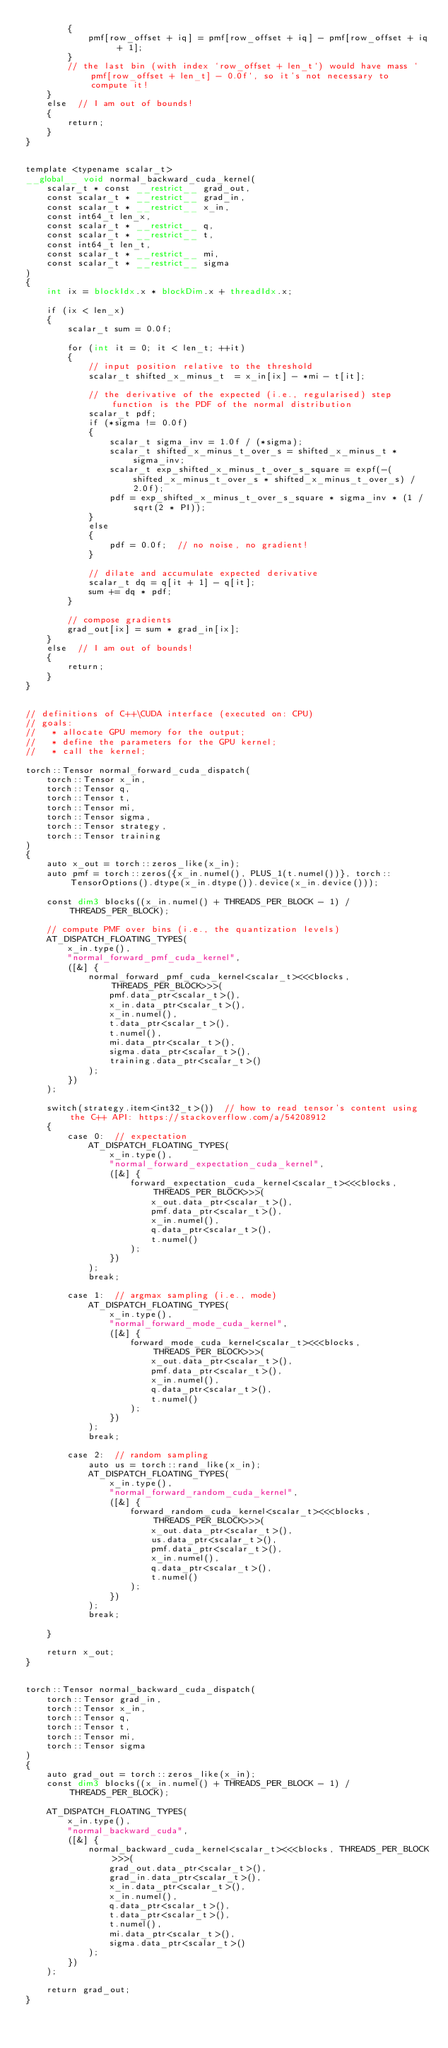<code> <loc_0><loc_0><loc_500><loc_500><_Cuda_>        {
            pmf[row_offset + iq] = pmf[row_offset + iq] - pmf[row_offset + iq + 1];
        }
        // the last bin (with index `row_offset + len_t`) would have mass `pmf[row_offset + len_t] - 0.0f`, so it's not necessary to compute it!
    }
    else  // I am out of bounds!
    {
        return;
    }
}


template <typename scalar_t>
__global__ void normal_backward_cuda_kernel(
    scalar_t * const __restrict__ grad_out,
    const scalar_t * __restrict__ grad_in,
    const scalar_t * __restrict__ x_in,
    const int64_t len_x,
    const scalar_t * __restrict__ q,
    const scalar_t * __restrict__ t,
    const int64_t len_t,
    const scalar_t * __restrict__ mi,
    const scalar_t * __restrict__ sigma
)
{
    int ix = blockIdx.x * blockDim.x + threadIdx.x;

    if (ix < len_x)
    {
        scalar_t sum = 0.0f;

        for (int it = 0; it < len_t; ++it)
        {
            // input position relative to the threshold
            scalar_t shifted_x_minus_t  = x_in[ix] - *mi - t[it];

            // the derivative of the expected (i.e., regularised) step function is the PDF of the normal distribution
            scalar_t pdf;
            if (*sigma != 0.0f)
            {
                scalar_t sigma_inv = 1.0f / (*sigma);
                scalar_t shifted_x_minus_t_over_s = shifted_x_minus_t * sigma_inv;
                scalar_t exp_shifted_x_minus_t_over_s_square = expf(-(shifted_x_minus_t_over_s * shifted_x_minus_t_over_s) / 2.0f);
                pdf = exp_shifted_x_minus_t_over_s_square * sigma_inv * (1 / sqrt(2 * PI));
            }
            else
            {
                pdf = 0.0f;  // no noise, no gradient!
            }

            // dilate and accumulate expected derivative
            scalar_t dq = q[it + 1] - q[it];
            sum += dq * pdf;
        }

        // compose gradients
        grad_out[ix] = sum * grad_in[ix];
    }
    else  // I am out of bounds!
    {
        return;
    }
}


// definitions of C++\CUDA interface (executed on: CPU)
// goals:
//   * allocate GPU memory for the output;
//   * define the parameters for the GPU kernel;
//   * call the kernel;

torch::Tensor normal_forward_cuda_dispatch(
    torch::Tensor x_in,
    torch::Tensor q,
    torch::Tensor t,
    torch::Tensor mi,
    torch::Tensor sigma,
    torch::Tensor strategy,
    torch::Tensor training
)
{
    auto x_out = torch::zeros_like(x_in);
    auto pmf = torch::zeros({x_in.numel(), PLUS_1(t.numel())}, torch::TensorOptions().dtype(x_in.dtype()).device(x_in.device()));

    const dim3 blocks((x_in.numel() + THREADS_PER_BLOCK - 1) / THREADS_PER_BLOCK);

    // compute PMF over bins (i.e., the quantization levels)
    AT_DISPATCH_FLOATING_TYPES(
        x_in.type(),
        "normal_forward_pmf_cuda_kernel",
        ([&] {
            normal_forward_pmf_cuda_kernel<scalar_t><<<blocks, THREADS_PER_BLOCK>>>(
                pmf.data_ptr<scalar_t>(),
                x_in.data_ptr<scalar_t>(),
                x_in.numel(),
                t.data_ptr<scalar_t>(),
                t.numel(),
                mi.data_ptr<scalar_t>(),
                sigma.data_ptr<scalar_t>(),
                training.data_ptr<scalar_t>()
            );
        })
    );

    switch(strategy.item<int32_t>())  // how to read tensor's content using the C++ API: https://stackoverflow.com/a/54208912
    {
        case 0:  // expectation
            AT_DISPATCH_FLOATING_TYPES(
                x_in.type(),
                "normal_forward_expectation_cuda_kernel",
                ([&] {
                    forward_expectation_cuda_kernel<scalar_t><<<blocks, THREADS_PER_BLOCK>>>(
                        x_out.data_ptr<scalar_t>(),
                        pmf.data_ptr<scalar_t>(),
                        x_in.numel(),
                        q.data_ptr<scalar_t>(),
                        t.numel()
                    );
                })
            );
            break;

        case 1:  // argmax sampling (i.e., mode)
            AT_DISPATCH_FLOATING_TYPES(
                x_in.type(),
                "normal_forward_mode_cuda_kernel",
                ([&] {
                    forward_mode_cuda_kernel<scalar_t><<<blocks, THREADS_PER_BLOCK>>>(
                        x_out.data_ptr<scalar_t>(),
                        pmf.data_ptr<scalar_t>(),
                        x_in.numel(),
                        q.data_ptr<scalar_t>(),
                        t.numel()
                    );
                })
            );
            break;

        case 2:  // random sampling
            auto us = torch::rand_like(x_in);
            AT_DISPATCH_FLOATING_TYPES(
                x_in.type(),
                "normal_forward_random_cuda_kernel",
                ([&] {
                    forward_random_cuda_kernel<scalar_t><<<blocks, THREADS_PER_BLOCK>>>(
                        x_out.data_ptr<scalar_t>(),
                        us.data_ptr<scalar_t>(),
                        pmf.data_ptr<scalar_t>(),
                        x_in.numel(),
                        q.data_ptr<scalar_t>(),
                        t.numel()
                    );
                })
            );
            break;

    }

    return x_out;
}


torch::Tensor normal_backward_cuda_dispatch(
    torch::Tensor grad_in,
    torch::Tensor x_in,
    torch::Tensor q,
    torch::Tensor t,
    torch::Tensor mi,
    torch::Tensor sigma
)
{
    auto grad_out = torch::zeros_like(x_in);
    const dim3 blocks((x_in.numel() + THREADS_PER_BLOCK - 1) / THREADS_PER_BLOCK);

    AT_DISPATCH_FLOATING_TYPES(
        x_in.type(),
        "normal_backward_cuda",
        ([&] {
            normal_backward_cuda_kernel<scalar_t><<<blocks, THREADS_PER_BLOCK>>>(
                grad_out.data_ptr<scalar_t>(),
                grad_in.data_ptr<scalar_t>(),
                x_in.data_ptr<scalar_t>(),
                x_in.numel(),
                q.data_ptr<scalar_t>(),
                t.data_ptr<scalar_t>(),
                t.numel(),
                mi.data_ptr<scalar_t>(),
                sigma.data_ptr<scalar_t>()
            );
        })
    );

    return grad_out;
}
</code> 